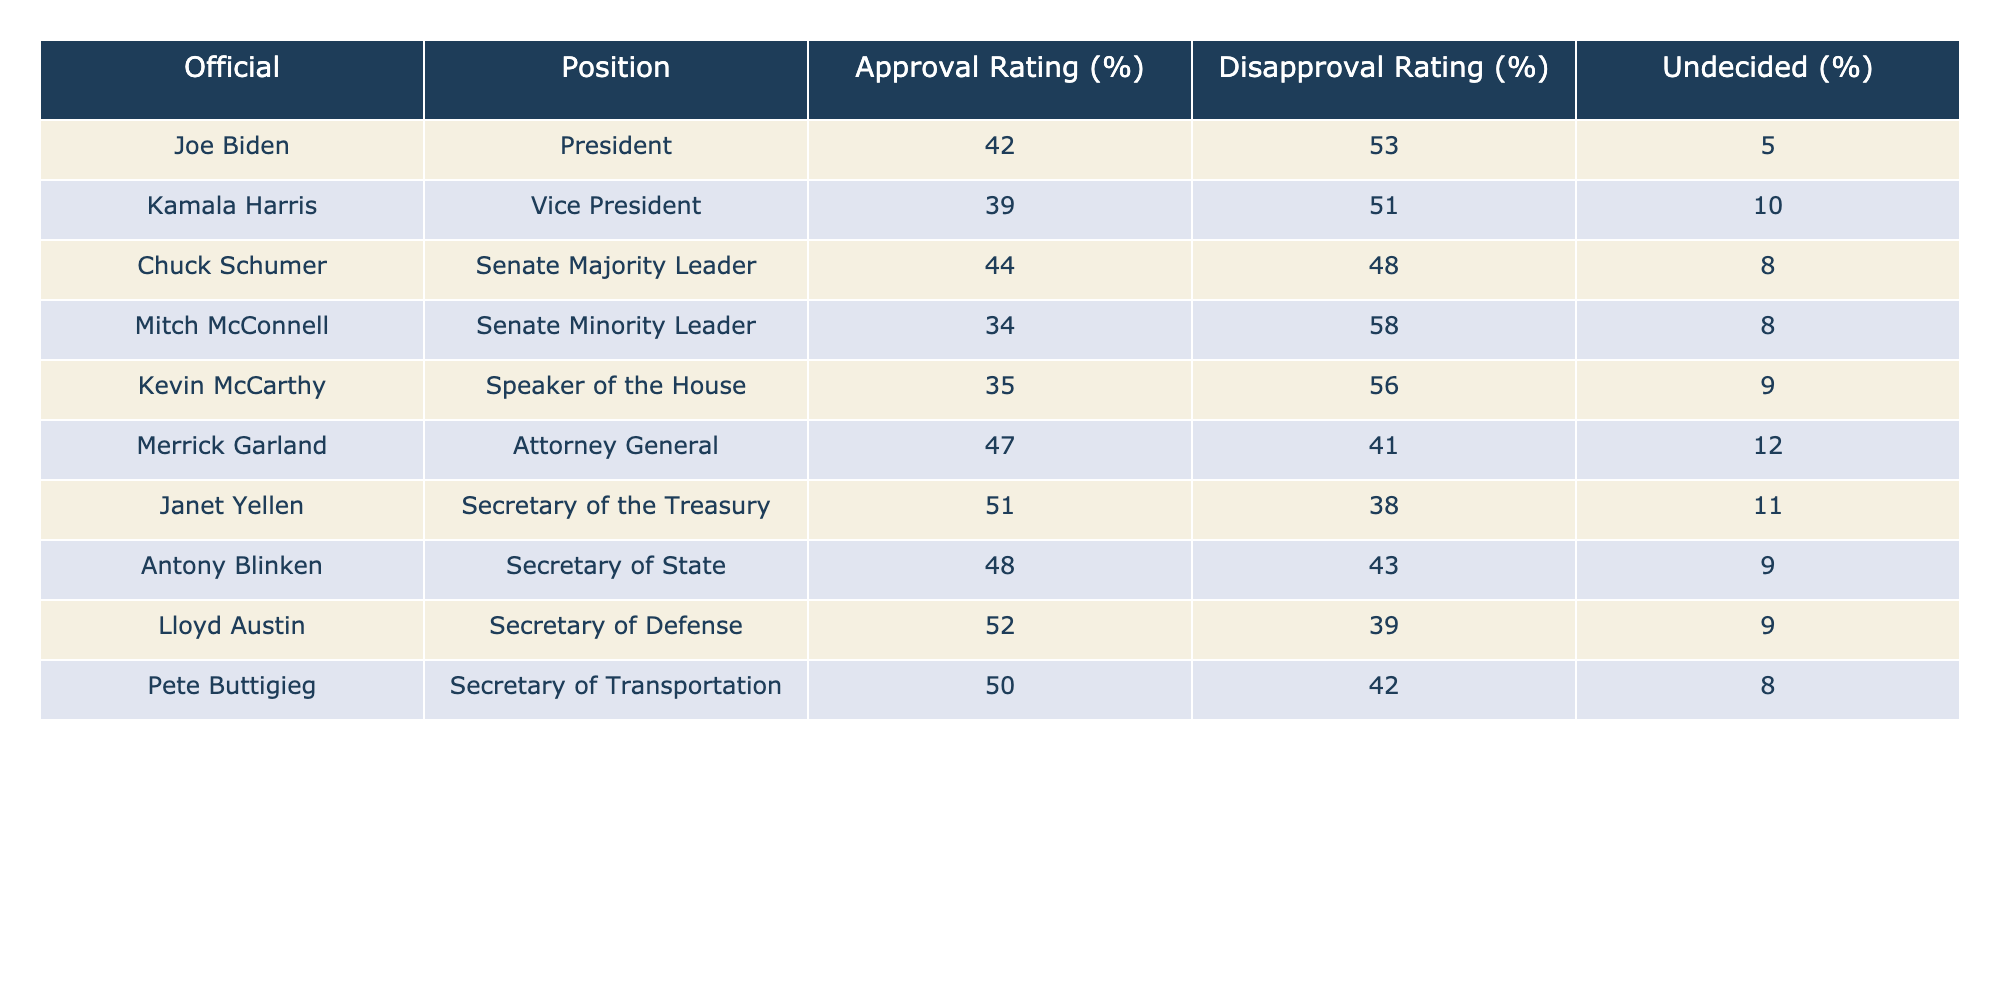What is Joe Biden's approval rating? Joe Biden's approval rating is listed directly in the table under the Approval Rating column for his position as President. The value is 42%.
Answer: 42% Who has the highest approval rating among the officials listed? Looking at the Approval Rating column, Janet Yellen has the highest rating at 51%.
Answer: 51% What is the disapproval rating for Kamala Harris? The disapproval rating for Kamala Harris is found in the Disapproval Rating column corresponding to her position as Vice President, which is 51%.
Answer: 51% Is Mitch McConnell's approval rating above 30%? The approval rating for Mitch McConnell is 34%, which is above 30%.
Answer: Yes What is the average approval rating of the officials listed? To find the average approval rating, add together all the individual approval ratings: (42 + 39 + 44 + 34 + 35 + 47 + 51 + 48 + 52 + 50) = 442 and divide by the number of officials, which is 10. So, the average approval rating is 442/10 = 44.2%.
Answer: 44.2% Who has the lowest disapproval rating? By evaluating the Disapproval Rating column, we see that Merrick Garland has the lowest disapproval rating, at 41%.
Answer: 41% What percentage of people are undecided about Kevin McCarthy? This value is found in the Undecided column for Kevin McCarthy, which indicates that 9% of people are undecided.
Answer: 9% Is the difference between approval ratings for Lloyd Austin and Pete Buttigieg greater than 2%? Lloyd Austin has an approval rating of 52% and Pete Buttigieg has 50%. The difference is 52 - 50 = 2%, which is not greater than 2%.
Answer: No What is the combined approval rating of the Senate leaders Chuck Schumer and Mitch McConnell? Adding the approval ratings for Chuck Schumer (44%) and Mitch McConnell (34%) gives us 44 + 34 = 78%.
Answer: 78% 